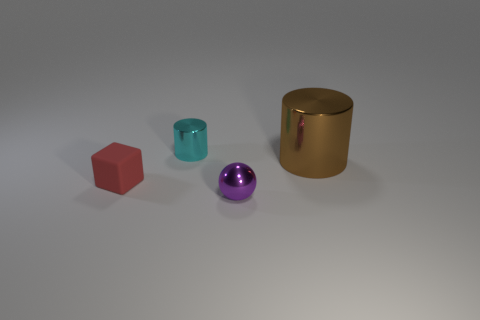There is a metal thing in front of the cylinder in front of the tiny cylinder; is there a tiny purple ball behind it? no 